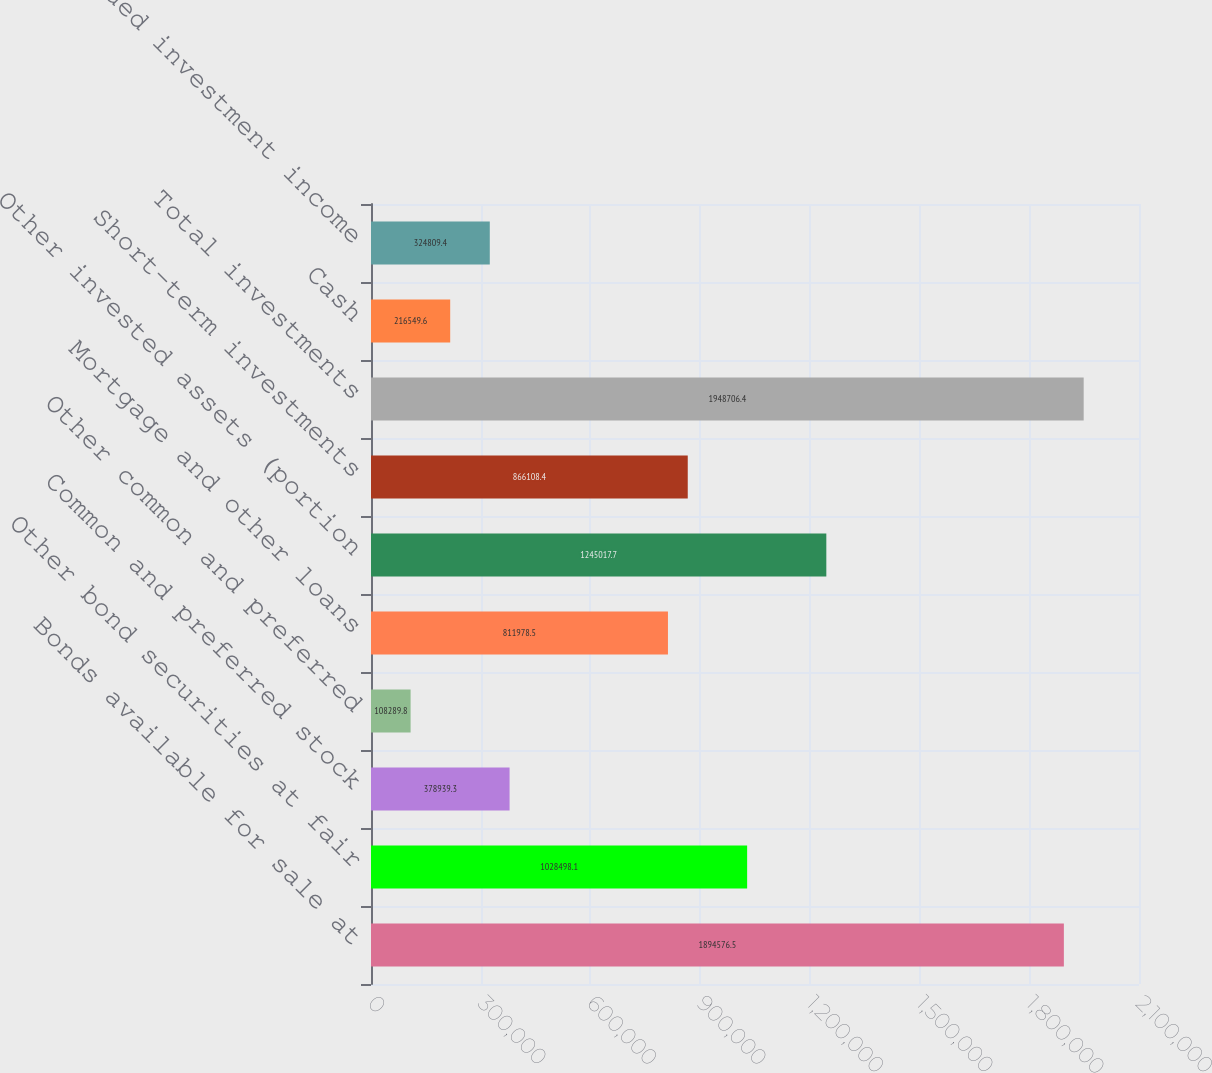Convert chart to OTSL. <chart><loc_0><loc_0><loc_500><loc_500><bar_chart><fcel>Bonds available for sale at<fcel>Other bond securities at fair<fcel>Common and preferred stock<fcel>Other common and preferred<fcel>Mortgage and other loans<fcel>Other invested assets (portion<fcel>Short-term investments<fcel>Total investments<fcel>Cash<fcel>Accrued investment income<nl><fcel>1.89458e+06<fcel>1.0285e+06<fcel>378939<fcel>108290<fcel>811978<fcel>1.24502e+06<fcel>866108<fcel>1.94871e+06<fcel>216550<fcel>324809<nl></chart> 